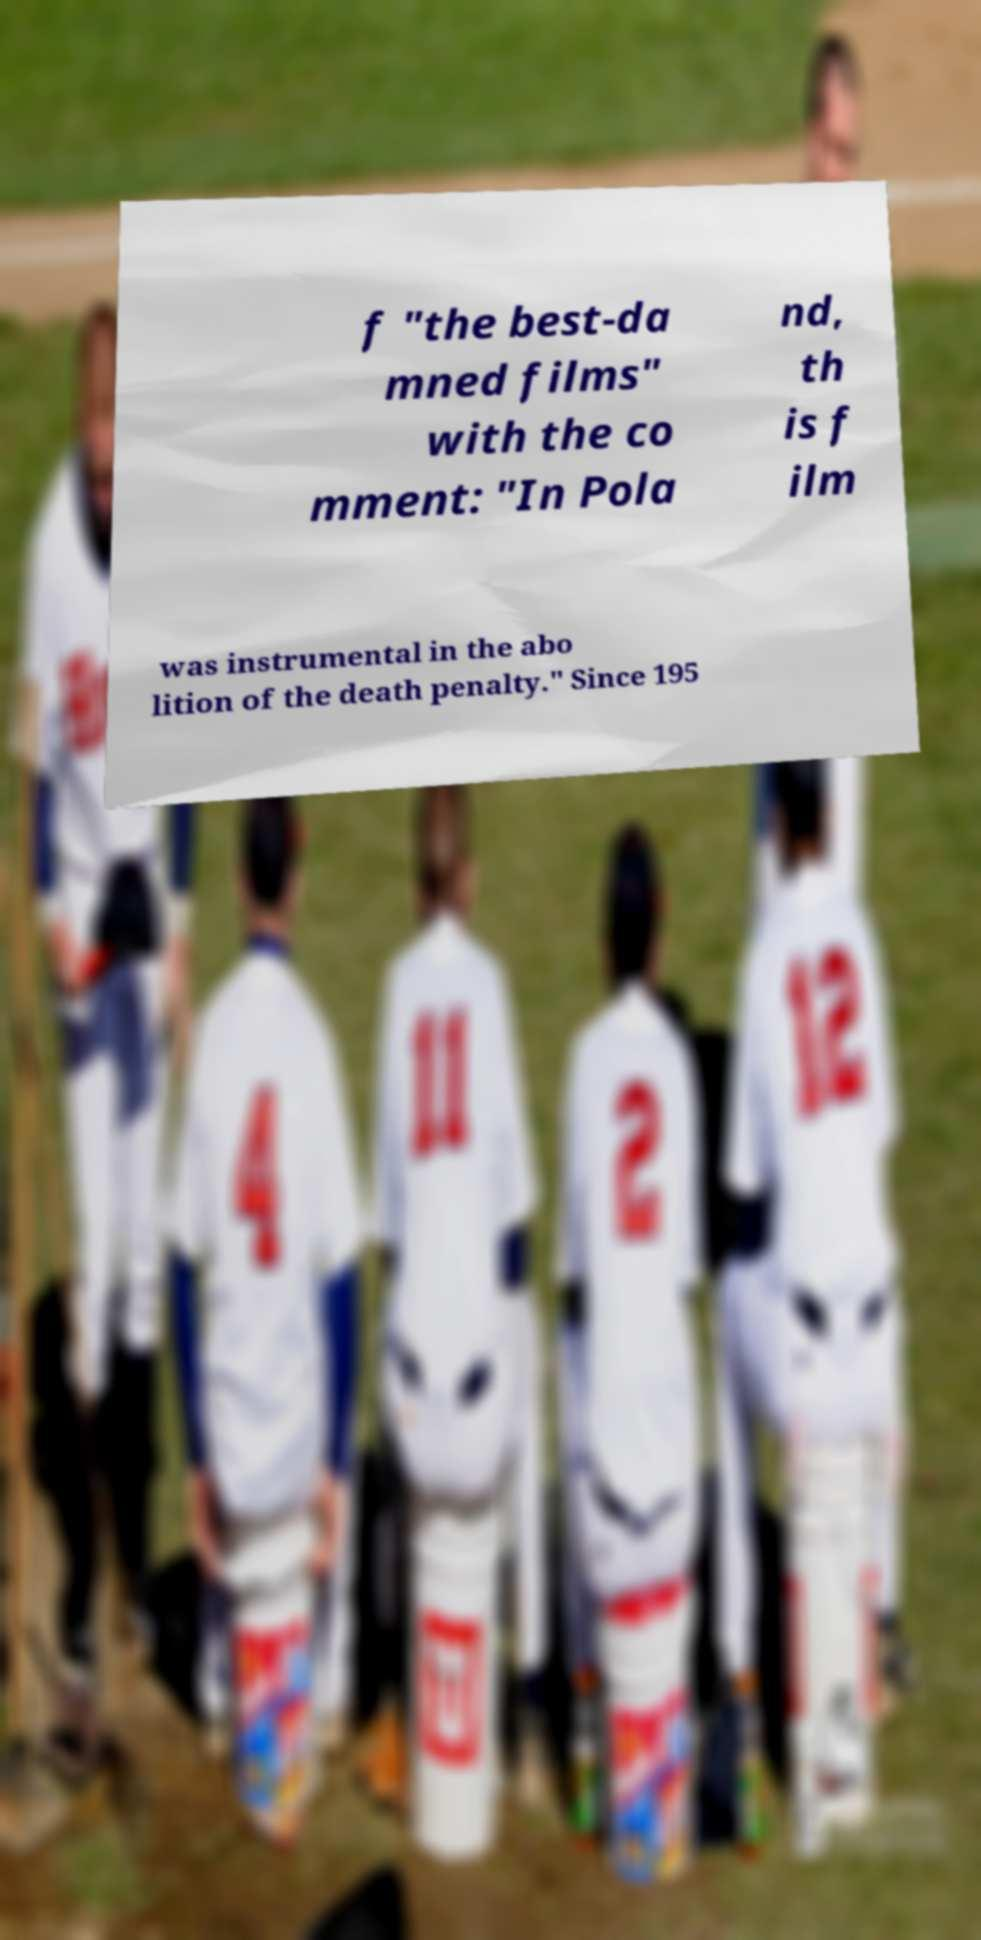Can you read and provide the text displayed in the image?This photo seems to have some interesting text. Can you extract and type it out for me? f "the best-da mned films" with the co mment: "In Pola nd, th is f ilm was instrumental in the abo lition of the death penalty." Since 195 